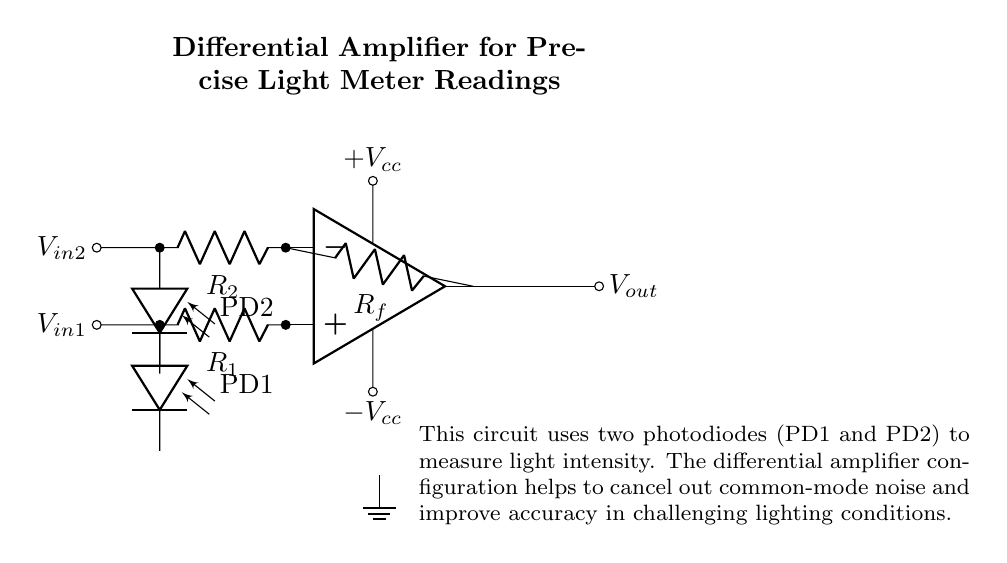What are the input components of this circuit? The input components are two photodiodes labeled PD1 and PD2. Each photodiode is connected to the non-inverting and inverting inputs of the operational amplifier.
Answer: Photodiodes What is the role of the feedback resistor in this circuit? The feedback resistor, labeled Rf, connects the output to the inverting input of the operational amplifier, which helps to set the gain of the amplifier and stabilize the circuit.
Answer: Feedback resistor What type of amplifier is shown in this diagram? The diagram depicts a differential amplifier that measures the difference between two input voltages provided by the photodiodes, which is key for minimizing noise and fluctuations in light readings.
Answer: Differential amplifier What is the significance of the power supply voltages? The power supply voltages, labeled +Vcc and -Vcc, provide the necessary voltage levels for the operational amplifier to function properly, allowing it to amplify the input signals from the photodiodes.
Answer: Power supply voltages How does this circuit improve accuracy under varying lighting conditions? The differential amplifier configuration cancels out common-mode signals (noise) that affect both inputs equally, allowing only the actual difference in light intensity to be amplified, leading to more precise readings.
Answer: Common-mode noise cancellation 